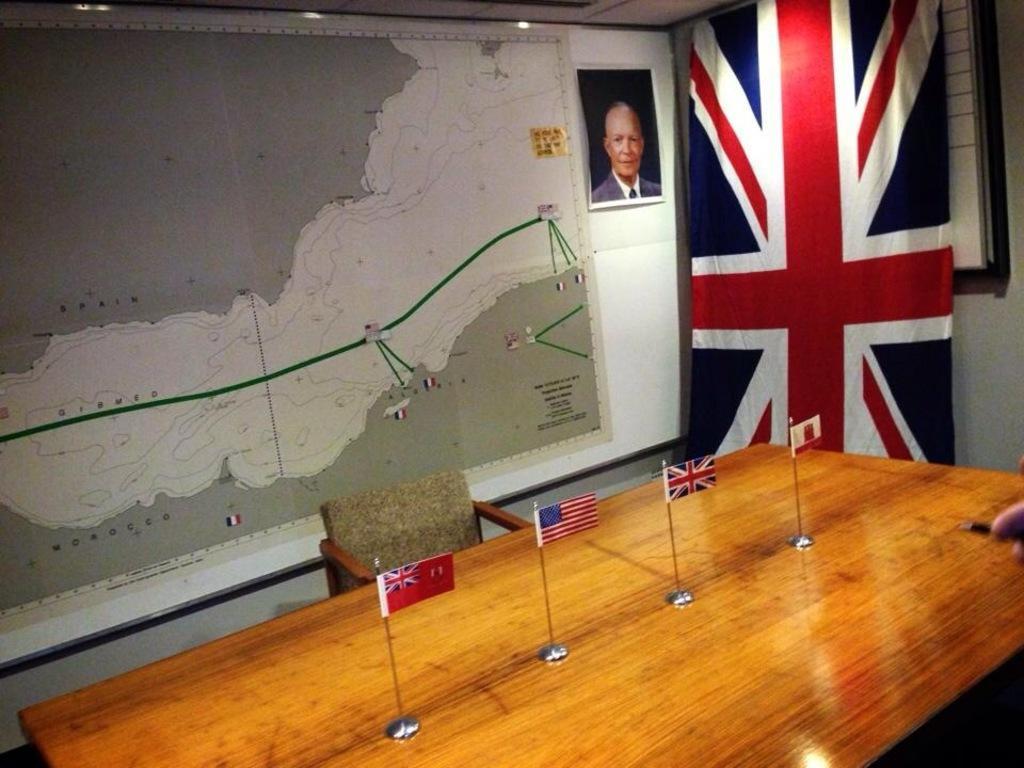How would you summarize this image in a sentence or two? This image is taken inside a room. At the bottom of the image there is a table and there were four flags on it. At the background there is a map on the wall and a photo frame, besides that a flag is there on the wall. In the middle of the image an empty chair is there. 